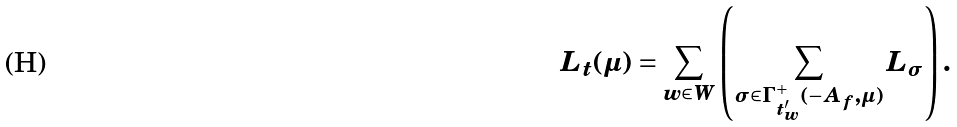Convert formula to latex. <formula><loc_0><loc_0><loc_500><loc_500>L _ { t } ( \mu ) = \sum _ { w \in W } \left ( \sum _ { \sigma \in \Gamma ^ { + } _ { t _ { w } ^ { \prime } } ( - A _ { f } , \mu ) } L _ { \sigma } \right ) .</formula> 